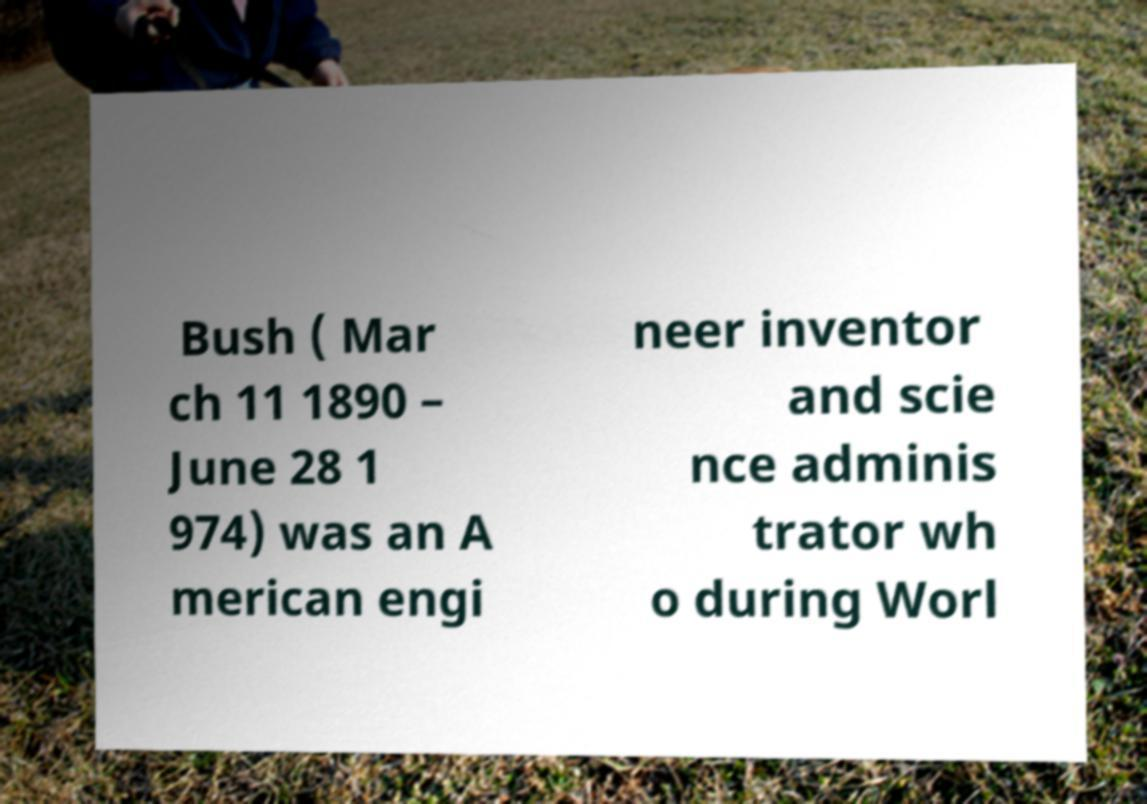I need the written content from this picture converted into text. Can you do that? Bush ( Mar ch 11 1890 – June 28 1 974) was an A merican engi neer inventor and scie nce adminis trator wh o during Worl 